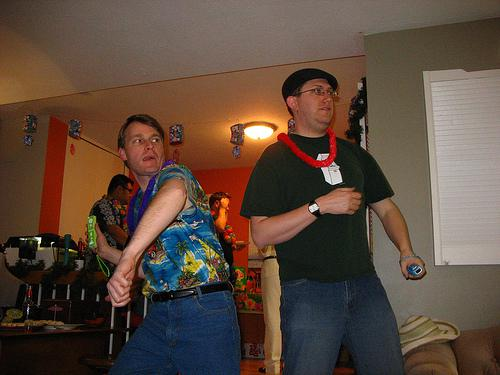Question: where was the photo taken?
Choices:
A. In the dinning room.
B. In the kitchen.
C. At a restaurant.
D. In a living room in a home.
Answer with the letter. Answer: D Question: who has on a green shirt?
Choices:
A. The man on the right.
B. The woman.
C. The child.
D. The dog.
Answer with the letter. Answer: A Question: what is white?
Choices:
A. Walls.
B. Shoes.
C. Shirts.
D. Ceiling.
Answer with the letter. Answer: D Question: why are the men holding game controllers?
Choices:
A. To play a video game.
B. To comete in a video game tournament.
C. To show off their new purchases.
D. To model new controllers for a new company.
Answer with the letter. Answer: A Question: where is a light?
Choices:
A. In the hallway.
B. Outside.
C. In the living room.
D. On the ceiling.
Answer with the letter. Answer: D Question: what is closed?
Choices:
A. Blinds.
B. The door.
C. The windows.
D. The freezer.
Answer with the letter. Answer: A Question: how many men are playing a video game?
Choices:
A. Three.
B. Four.
C. Five.
D. Two.
Answer with the letter. Answer: D Question: who is wearing a blue shirt?
Choices:
A. The woman on the right.
B. My brother.
C. The man on left.
D. My friend.
Answer with the letter. Answer: C 